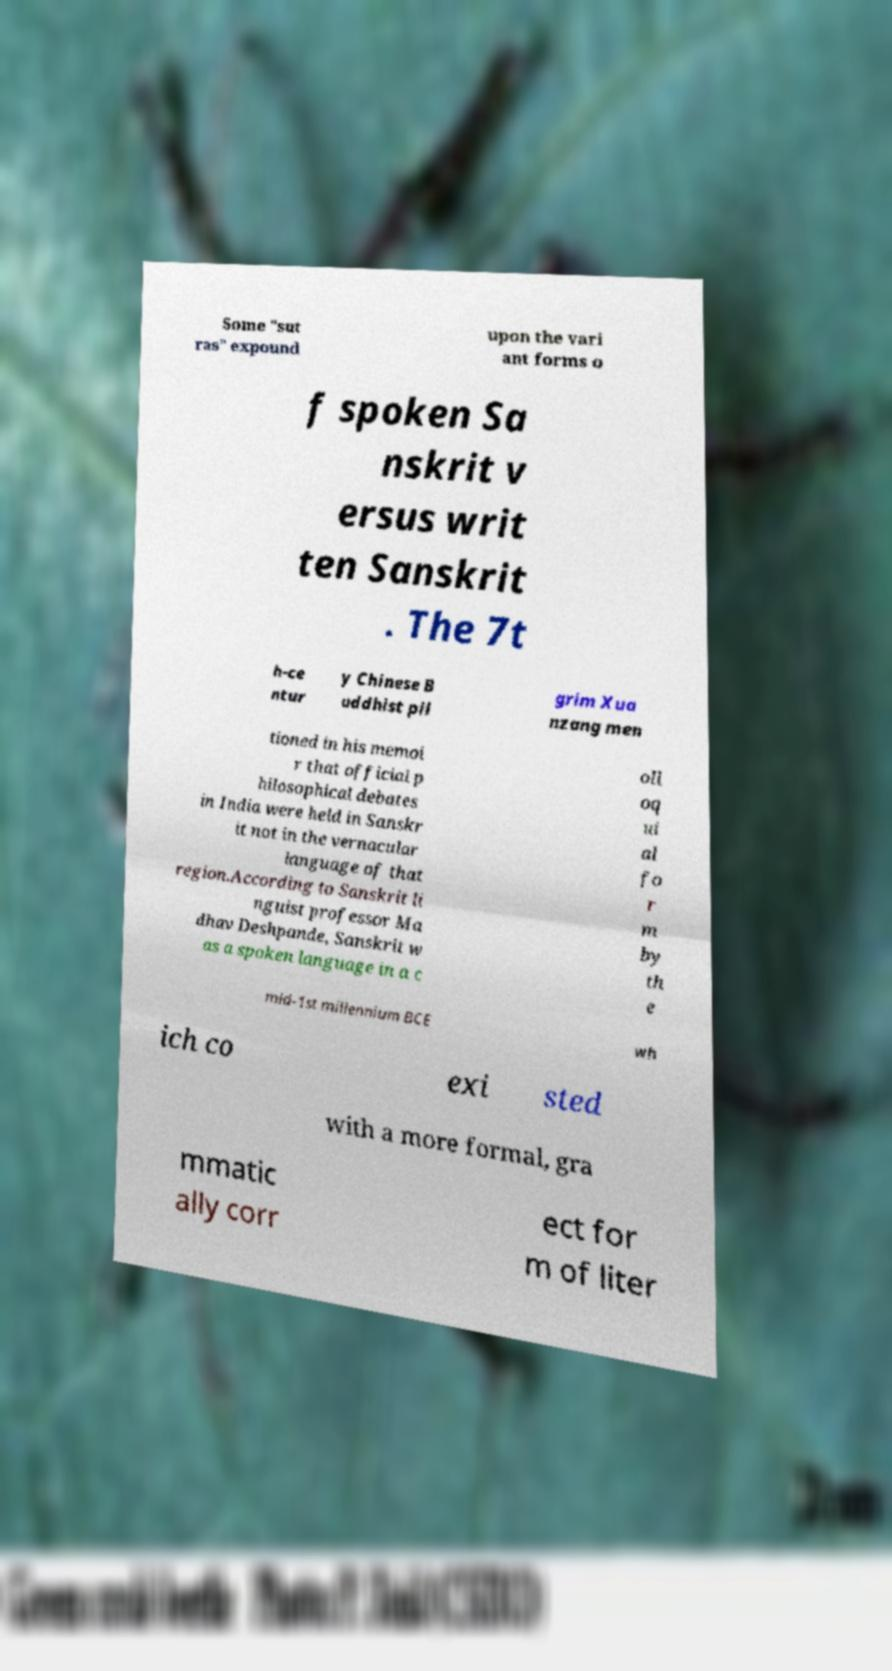Please read and relay the text visible in this image. What does it say? Some "sut ras" expound upon the vari ant forms o f spoken Sa nskrit v ersus writ ten Sanskrit . The 7t h-ce ntur y Chinese B uddhist pil grim Xua nzang men tioned in his memoi r that official p hilosophical debates in India were held in Sanskr it not in the vernacular language of that region.According to Sanskrit li nguist professor Ma dhav Deshpande, Sanskrit w as a spoken language in a c oll oq ui al fo r m by th e mid-1st millennium BCE wh ich co exi sted with a more formal, gra mmatic ally corr ect for m of liter 